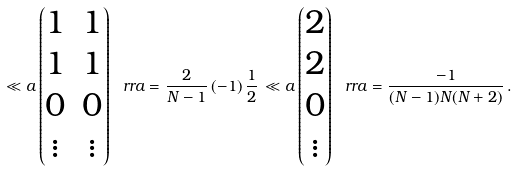<formula> <loc_0><loc_0><loc_500><loc_500>\ll a \begin{pmatrix} 1 & 1 \\ 1 & 1 \\ 0 & 0 \\ \vdots & \vdots \end{pmatrix} \ r r a = \frac { 2 } { N - 1 } \, ( - 1 ) \, \frac { 1 } { 2 } \, \ll a \begin{pmatrix} 2 \\ 2 \\ 0 \\ \vdots \end{pmatrix} \ r r a = \frac { - 1 } { ( N - 1 ) N ( N + 2 ) } \, .</formula> 